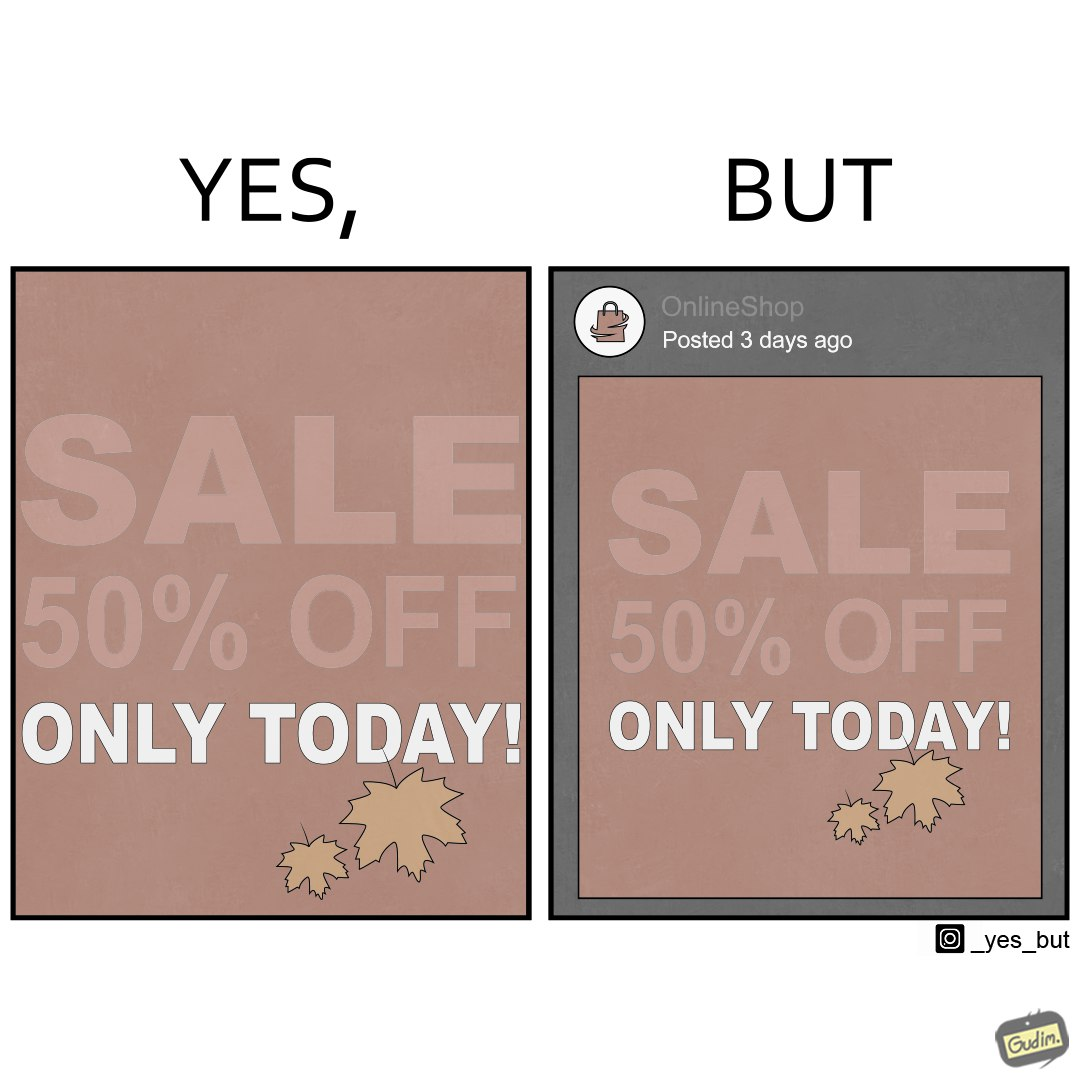Explain why this image is satirical. The image is ironic, because the poster of sale at a store is posted 3 days ago on a social media account which means the sale which was for only one day has become over 